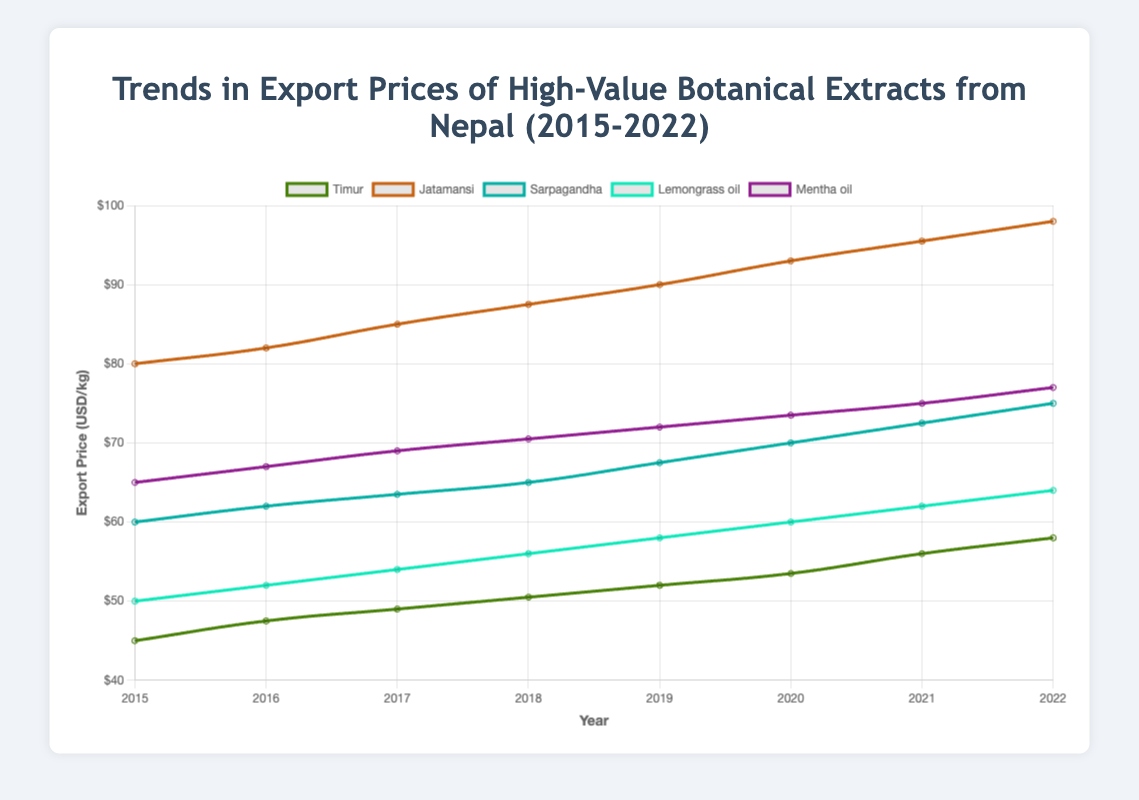What was the export price difference for jatamansi between 2015 and 2022? The export price of jatamansi in 2015 was $80.0, and in 2022 it was $98.0. The difference is calculated by subtracting the 2015 price from the 2022 price: $98.0 - $80.0 = $18.0
Answer: $18.0 Between which years did lemongrass oil see the biggest increase in export price? To find the biggest increase, compare the year-to-year differences: 
2015-2016: $52.0 - $50.0 = $2.0,
2016-2017: $54.0 - $52.0 = $2.0,
2017-2018: $56.0 - $54.0 = $2.0,
2018-2019: $58.0 - $56.0 = $2.0,
2019-2020: $60.0 - $58.0 = $2.0,
2020-2021: $62.0 - $60.0 = $2.0,
2021-2022: $64.0 - $62.0 = $2.0. 
Since the increases are same, all the periods had the same increase of $2.0
Answer: All years had the same increase of $2.0 Which product had the highest overall increase in export price from 2015 to 2022? Calculate the difference for each product.
Timur: $58.0 - $45.0 = $13.0,
Jatamansi: $98.0 - $80.0 = $18.0,
Sarpagandha: $75.0 - $60.0 = $15.0,
Lemongrass oil: $64.0 - $50.0 = $14.0,
Mentha oil: $77.0 - $65.0 = $12.0.
The highest increase is for jatamansi: $18.0
Answer: Jatamansi Did any product's export price decrease during the observed period from 2015 to 2022? By examining the export prices for each product from 2015 to 2022, we can see that all products show a steady increase in their prices, with no decreases observed.
Answer: No What is the average export price for mentha oil over the years 2018 to 2020? The export prices for mentha oil from 2018 to 2020 are $70.5, $72.0, and $73.5. The average is calculated as:
($70.5 + $72.0 + $73.5) / 3 = 216.0 / 3 = $72.0
Answer: $72.0 Which two products had the closest export prices in 2021? The export prices in 2021 are:
Timur: $56.0,
Jatamansi: $95.5,
Sarpagandha: $72.5,
Lemongrass oil: $62.0,
Mentha oil: $75.0.
The closest prices are for Lemongrass oil ($62.0) and Timur ($56.0), with a difference of $6.0.
Answer: Timur and Lemongrass oil What is the average annual increase in export price for sarpagandha over the period 2015-2022? The increase from 2015 to 2022 for sarpagandha is $75.0 - $60.0 = $15.0. There are 7 intervals (2015-2016, 2016-2017, ..., 2021-2022). The average annual increase is $15.0 / 7 ≈ $2.14
Answer: $2.14 